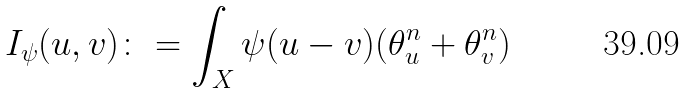Convert formula to latex. <formula><loc_0><loc_0><loc_500><loc_500>I _ { \psi } ( u , v ) \colon = \int _ { X } \psi ( u - v ) ( \theta ^ { n } _ { u } + \theta ^ { n } _ { v } )</formula> 